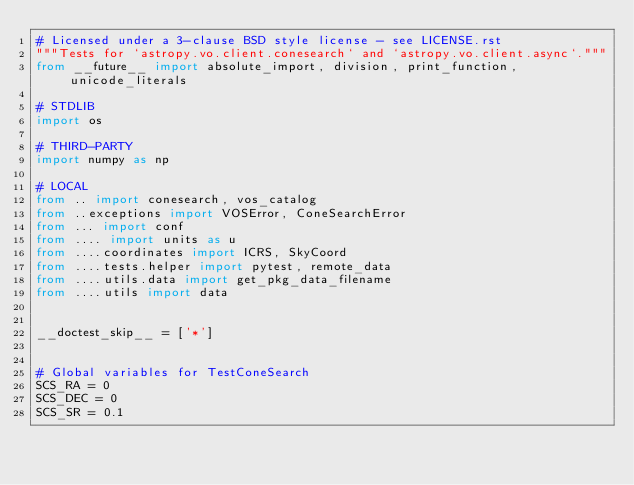Convert code to text. <code><loc_0><loc_0><loc_500><loc_500><_Python_># Licensed under a 3-clause BSD style license - see LICENSE.rst
"""Tests for `astropy.vo.client.conesearch` and `astropy.vo.client.async`."""
from __future__ import absolute_import, division, print_function, unicode_literals

# STDLIB
import os

# THIRD-PARTY
import numpy as np

# LOCAL
from .. import conesearch, vos_catalog
from ..exceptions import VOSError, ConeSearchError
from ... import conf
from .... import units as u
from ....coordinates import ICRS, SkyCoord
from ....tests.helper import pytest, remote_data
from ....utils.data import get_pkg_data_filename
from ....utils import data


__doctest_skip__ = ['*']


# Global variables for TestConeSearch
SCS_RA = 0
SCS_DEC = 0
SCS_SR = 0.1</code> 